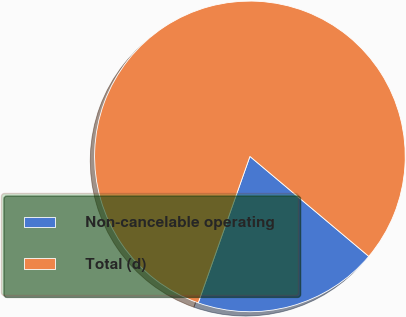Convert chart to OTSL. <chart><loc_0><loc_0><loc_500><loc_500><pie_chart><fcel>Non-cancelable operating<fcel>Total (d)<nl><fcel>19.27%<fcel>80.73%<nl></chart> 